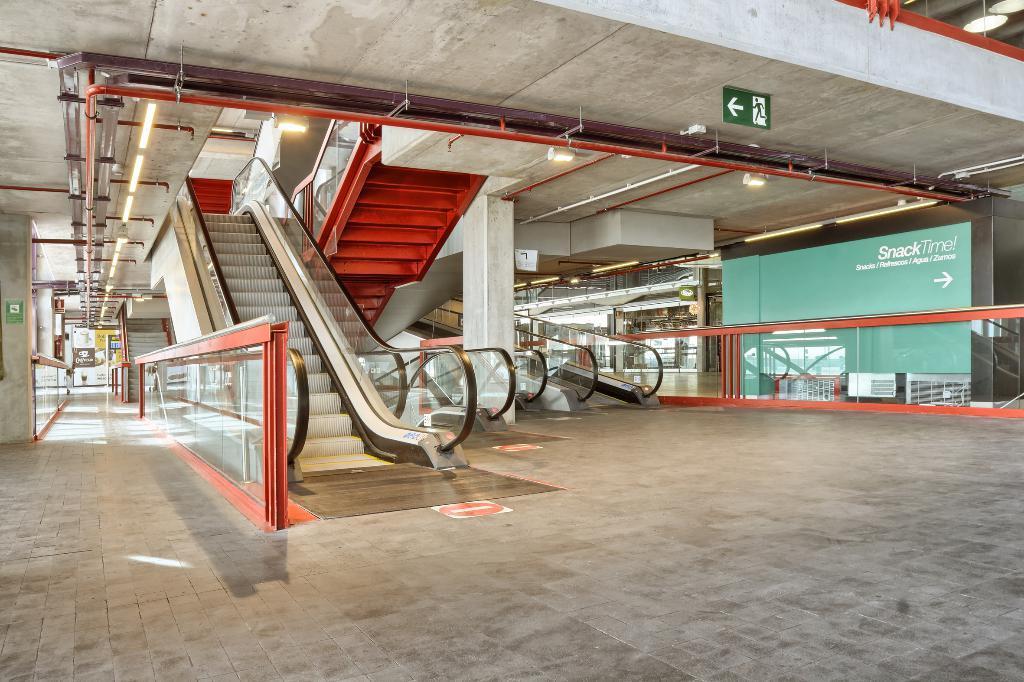Can you describe this image briefly? In this picture we can see the inside view of a building. Inside the building there are escalators and glass fencing. At the top there are ceiling lights and a signboard. On the right of the image, there is a board. Behind the escalators, there are some objects 